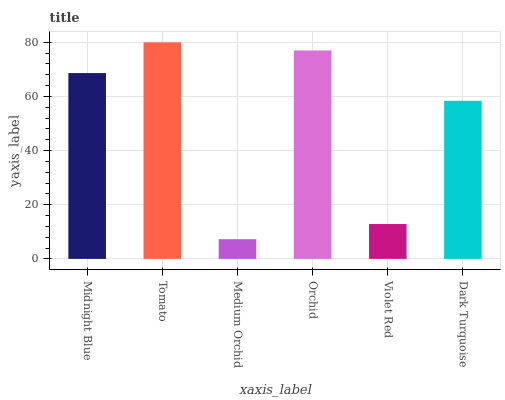Is Medium Orchid the minimum?
Answer yes or no. Yes. Is Tomato the maximum?
Answer yes or no. Yes. Is Tomato the minimum?
Answer yes or no. No. Is Medium Orchid the maximum?
Answer yes or no. No. Is Tomato greater than Medium Orchid?
Answer yes or no. Yes. Is Medium Orchid less than Tomato?
Answer yes or no. Yes. Is Medium Orchid greater than Tomato?
Answer yes or no. No. Is Tomato less than Medium Orchid?
Answer yes or no. No. Is Midnight Blue the high median?
Answer yes or no. Yes. Is Dark Turquoise the low median?
Answer yes or no. Yes. Is Medium Orchid the high median?
Answer yes or no. No. Is Violet Red the low median?
Answer yes or no. No. 